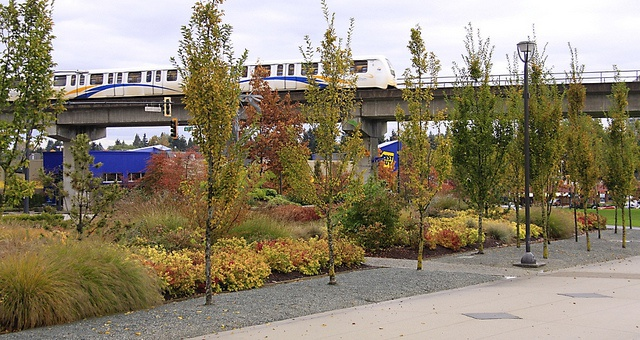Describe the objects in this image and their specific colors. I can see a train in lavender, white, gray, darkgray, and tan tones in this image. 